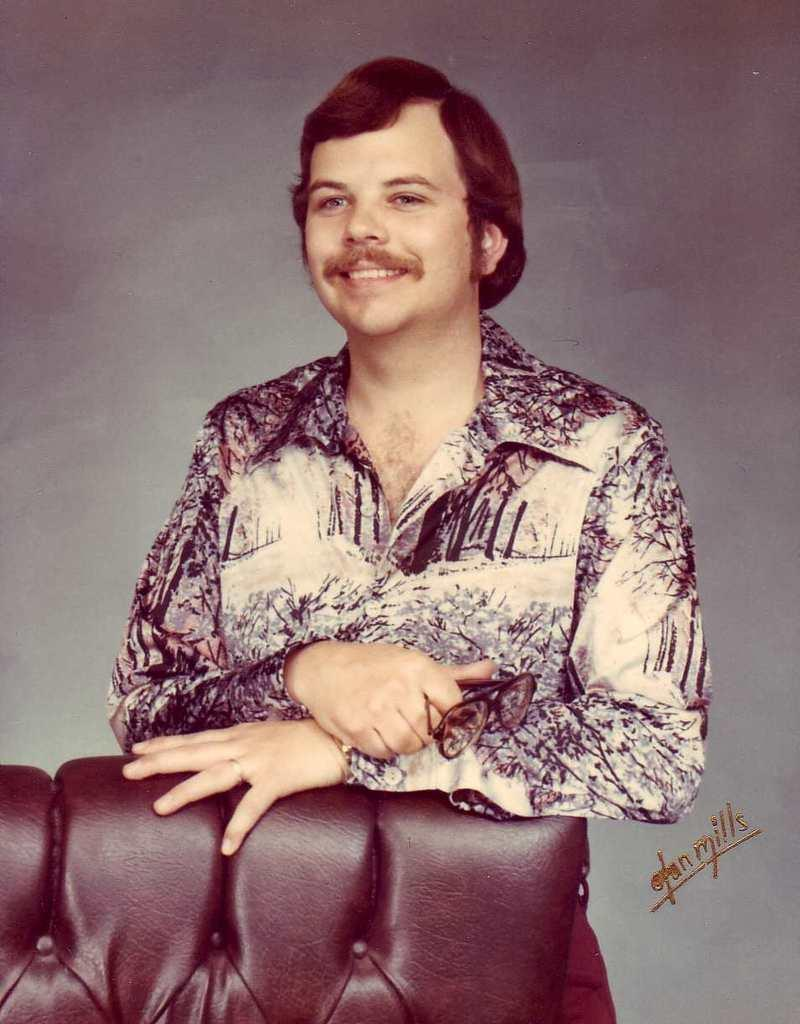What is the main subject of the picture? The main subject of the picture is a man. What is the man doing in the image? The man is standing and smiling in the image. What is the man holding in the picture? The man is holding goggles in the image. Can you describe the object in front of the man? There is an object in front of the man, but its specific details are not clear from the provided facts. What can be seen in the image besides the man and the object? There is text visible in the image. What is the color of the background in the image? The background of the image is grey. What type of cookware is visible in the image? There is no cookware present in the image. Can you describe the vase on the table in the image? There is no table or vase mentioned in the provided facts, so we cannot describe them. 